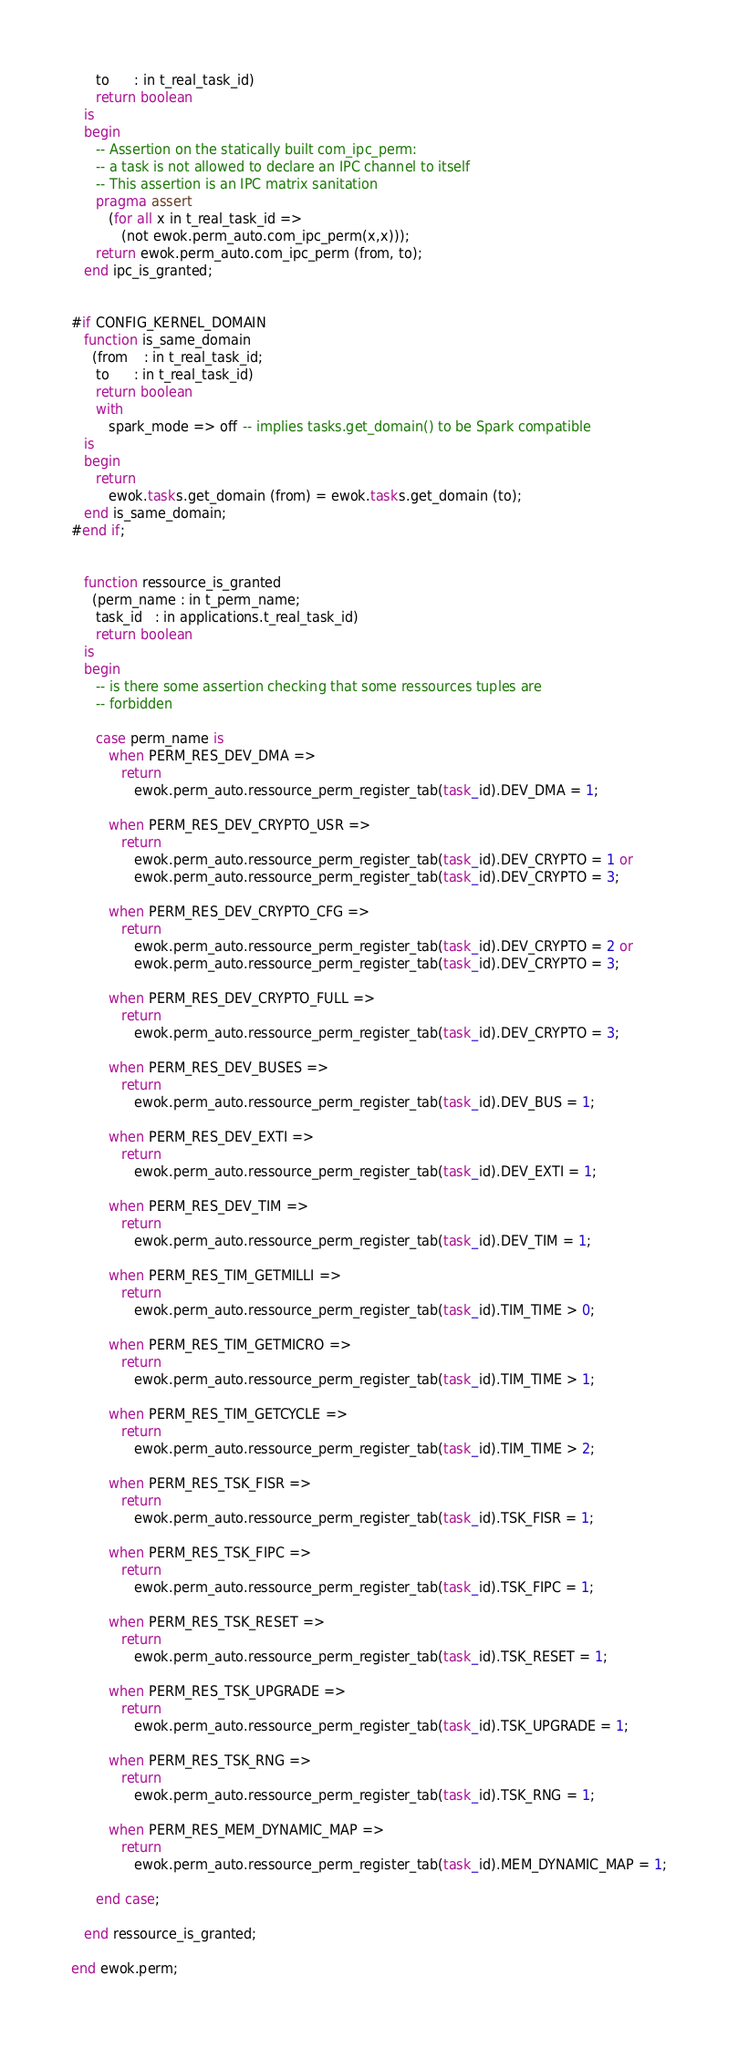<code> <loc_0><loc_0><loc_500><loc_500><_Ada_>      to      : in t_real_task_id)
      return boolean
   is
   begin
      -- Assertion on the statically built com_ipc_perm:
      -- a task is not allowed to declare an IPC channel to itself
      -- This assertion is an IPC matrix sanitation
      pragma assert
         (for all x in t_real_task_id =>
            (not ewok.perm_auto.com_ipc_perm(x,x)));
      return ewok.perm_auto.com_ipc_perm (from, to);
   end ipc_is_granted;


#if CONFIG_KERNEL_DOMAIN
   function is_same_domain
     (from    : in t_real_task_id;
      to      : in t_real_task_id)
      return boolean
      with
         spark_mode => off -- implies tasks.get_domain() to be Spark compatible
   is
   begin
      return
         ewok.tasks.get_domain (from) = ewok.tasks.get_domain (to);
   end is_same_domain;
#end if;


   function ressource_is_granted
     (perm_name : in t_perm_name;
      task_id   : in applications.t_real_task_id)
      return boolean
   is
   begin
      -- is there some assertion checking that some ressources tuples are
      -- forbidden

      case perm_name is
         when PERM_RES_DEV_DMA =>
            return
               ewok.perm_auto.ressource_perm_register_tab(task_id).DEV_DMA = 1;

         when PERM_RES_DEV_CRYPTO_USR =>
            return
               ewok.perm_auto.ressource_perm_register_tab(task_id).DEV_CRYPTO = 1 or
               ewok.perm_auto.ressource_perm_register_tab(task_id).DEV_CRYPTO = 3;

         when PERM_RES_DEV_CRYPTO_CFG =>
            return
               ewok.perm_auto.ressource_perm_register_tab(task_id).DEV_CRYPTO = 2 or
               ewok.perm_auto.ressource_perm_register_tab(task_id).DEV_CRYPTO = 3;

         when PERM_RES_DEV_CRYPTO_FULL =>
            return
               ewok.perm_auto.ressource_perm_register_tab(task_id).DEV_CRYPTO = 3;

         when PERM_RES_DEV_BUSES =>
            return
               ewok.perm_auto.ressource_perm_register_tab(task_id).DEV_BUS = 1;

         when PERM_RES_DEV_EXTI =>
            return
               ewok.perm_auto.ressource_perm_register_tab(task_id).DEV_EXTI = 1;

         when PERM_RES_DEV_TIM =>
            return
               ewok.perm_auto.ressource_perm_register_tab(task_id).DEV_TIM = 1;

         when PERM_RES_TIM_GETMILLI =>
            return
               ewok.perm_auto.ressource_perm_register_tab(task_id).TIM_TIME > 0;

         when PERM_RES_TIM_GETMICRO =>
            return
               ewok.perm_auto.ressource_perm_register_tab(task_id).TIM_TIME > 1;

         when PERM_RES_TIM_GETCYCLE =>
            return
               ewok.perm_auto.ressource_perm_register_tab(task_id).TIM_TIME > 2;

         when PERM_RES_TSK_FISR =>
            return
               ewok.perm_auto.ressource_perm_register_tab(task_id).TSK_FISR = 1;

         when PERM_RES_TSK_FIPC =>
            return
               ewok.perm_auto.ressource_perm_register_tab(task_id).TSK_FIPC = 1;

         when PERM_RES_TSK_RESET =>
            return
               ewok.perm_auto.ressource_perm_register_tab(task_id).TSK_RESET = 1;

         when PERM_RES_TSK_UPGRADE =>
            return
               ewok.perm_auto.ressource_perm_register_tab(task_id).TSK_UPGRADE = 1;

         when PERM_RES_TSK_RNG =>
            return
               ewok.perm_auto.ressource_perm_register_tab(task_id).TSK_RNG = 1;

         when PERM_RES_MEM_DYNAMIC_MAP =>
            return
               ewok.perm_auto.ressource_perm_register_tab(task_id).MEM_DYNAMIC_MAP = 1;

      end case;

   end ressource_is_granted;

end ewok.perm;
</code> 